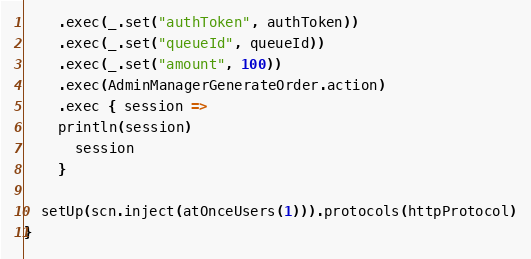<code> <loc_0><loc_0><loc_500><loc_500><_Scala_>    .exec(_.set("authToken", authToken))
    .exec(_.set("queueId", queueId))
    .exec(_.set("amount", 100))
    .exec(AdminManagerGenerateOrder.action)
    .exec { session =>
    println(session)
      session
    }

  setUp(scn.inject(atOnceUsers(1))).protocols(httpProtocol)
}
</code> 